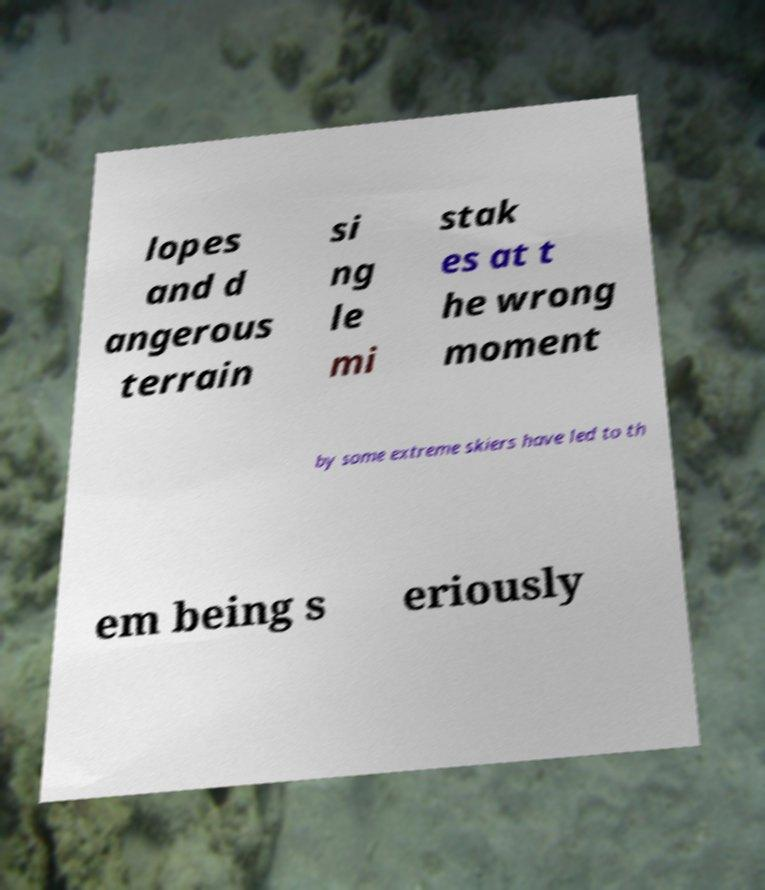Could you extract and type out the text from this image? lopes and d angerous terrain si ng le mi stak es at t he wrong moment by some extreme skiers have led to th em being s eriously 